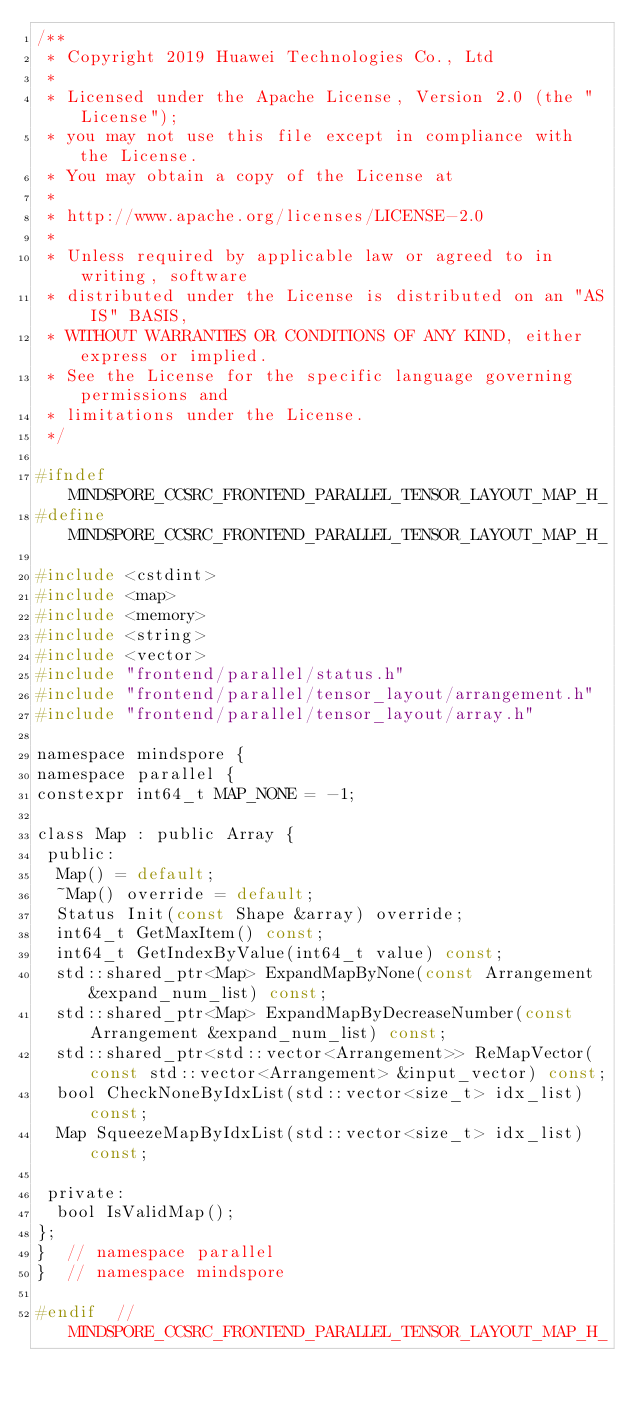Convert code to text. <code><loc_0><loc_0><loc_500><loc_500><_C_>/**
 * Copyright 2019 Huawei Technologies Co., Ltd
 *
 * Licensed under the Apache License, Version 2.0 (the "License");
 * you may not use this file except in compliance with the License.
 * You may obtain a copy of the License at
 *
 * http://www.apache.org/licenses/LICENSE-2.0
 *
 * Unless required by applicable law or agreed to in writing, software
 * distributed under the License is distributed on an "AS IS" BASIS,
 * WITHOUT WARRANTIES OR CONDITIONS OF ANY KIND, either express or implied.
 * See the License for the specific language governing permissions and
 * limitations under the License.
 */

#ifndef MINDSPORE_CCSRC_FRONTEND_PARALLEL_TENSOR_LAYOUT_MAP_H_
#define MINDSPORE_CCSRC_FRONTEND_PARALLEL_TENSOR_LAYOUT_MAP_H_

#include <cstdint>
#include <map>
#include <memory>
#include <string>
#include <vector>
#include "frontend/parallel/status.h"
#include "frontend/parallel/tensor_layout/arrangement.h"
#include "frontend/parallel/tensor_layout/array.h"

namespace mindspore {
namespace parallel {
constexpr int64_t MAP_NONE = -1;

class Map : public Array {
 public:
  Map() = default;
  ~Map() override = default;
  Status Init(const Shape &array) override;
  int64_t GetMaxItem() const;
  int64_t GetIndexByValue(int64_t value) const;
  std::shared_ptr<Map> ExpandMapByNone(const Arrangement &expand_num_list) const;
  std::shared_ptr<Map> ExpandMapByDecreaseNumber(const Arrangement &expand_num_list) const;
  std::shared_ptr<std::vector<Arrangement>> ReMapVector(const std::vector<Arrangement> &input_vector) const;
  bool CheckNoneByIdxList(std::vector<size_t> idx_list) const;
  Map SqueezeMapByIdxList(std::vector<size_t> idx_list) const;

 private:
  bool IsValidMap();
};
}  // namespace parallel
}  // namespace mindspore

#endif  // MINDSPORE_CCSRC_FRONTEND_PARALLEL_TENSOR_LAYOUT_MAP_H_
</code> 